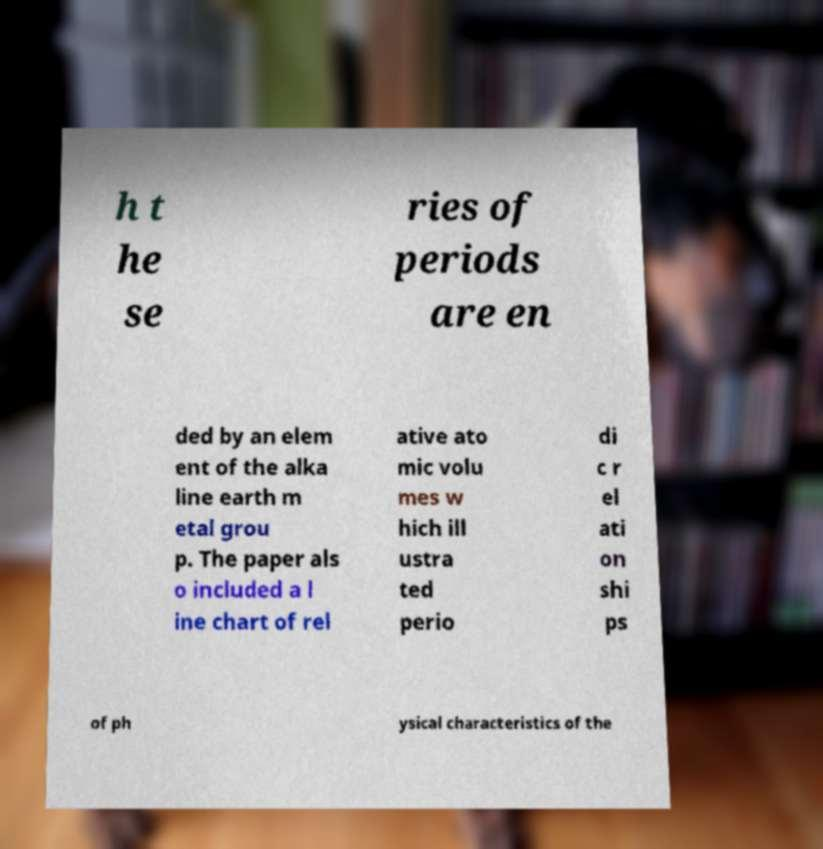I need the written content from this picture converted into text. Can you do that? h t he se ries of periods are en ded by an elem ent of the alka line earth m etal grou p. The paper als o included a l ine chart of rel ative ato mic volu mes w hich ill ustra ted perio di c r el ati on shi ps of ph ysical characteristics of the 